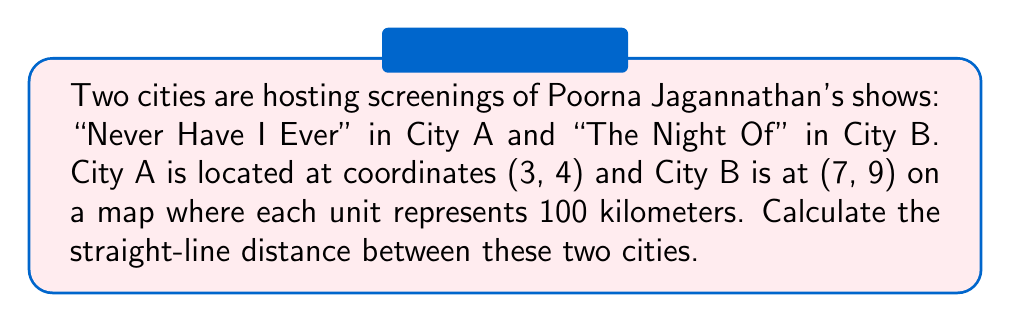Help me with this question. To solve this problem, we can use the distance formula derived from the Pythagorean theorem:

$$d = \sqrt{(x_2 - x_1)^2 + (y_2 - y_1)^2}$$

Where $(x_1, y_1)$ are the coordinates of City A and $(x_2, y_2)$ are the coordinates of City B.

Let's substitute the given values:
$(x_1, y_1) = (3, 4)$ for City A
$(x_2, y_2) = (7, 9)$ for City B

Now, let's calculate:

$$\begin{align*}
d &= \sqrt{(7 - 3)^2 + (9 - 4)^2} \\
&= \sqrt{4^2 + 5^2} \\
&= \sqrt{16 + 25} \\
&= \sqrt{41} \\
&\approx 6.403 \text{ units}
\end{align*}$$

Since each unit represents 100 kilometers, we need to multiply our result by 100:

$$6.403 \times 100 \approx 640.3 \text{ kilometers}$$

[asy]
import geometry;

scale(50);
dot((3,4));
dot((7,9));
draw((3,4)--(7,9), arrow=Arrow(TeXHead));
label("City A (3,4)", (3,4), SW);
label("City B (7,9)", (7,9), NE);
label("640.3 km", ((5,6.5)), SE);
[/asy]
Answer: The straight-line distance between the two cities screening Poorna Jagannathan's shows is approximately 640.3 kilometers. 